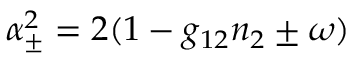<formula> <loc_0><loc_0><loc_500><loc_500>\alpha _ { \pm } ^ { 2 } = 2 ( 1 - g _ { 1 2 } n _ { 2 } \pm \omega )</formula> 